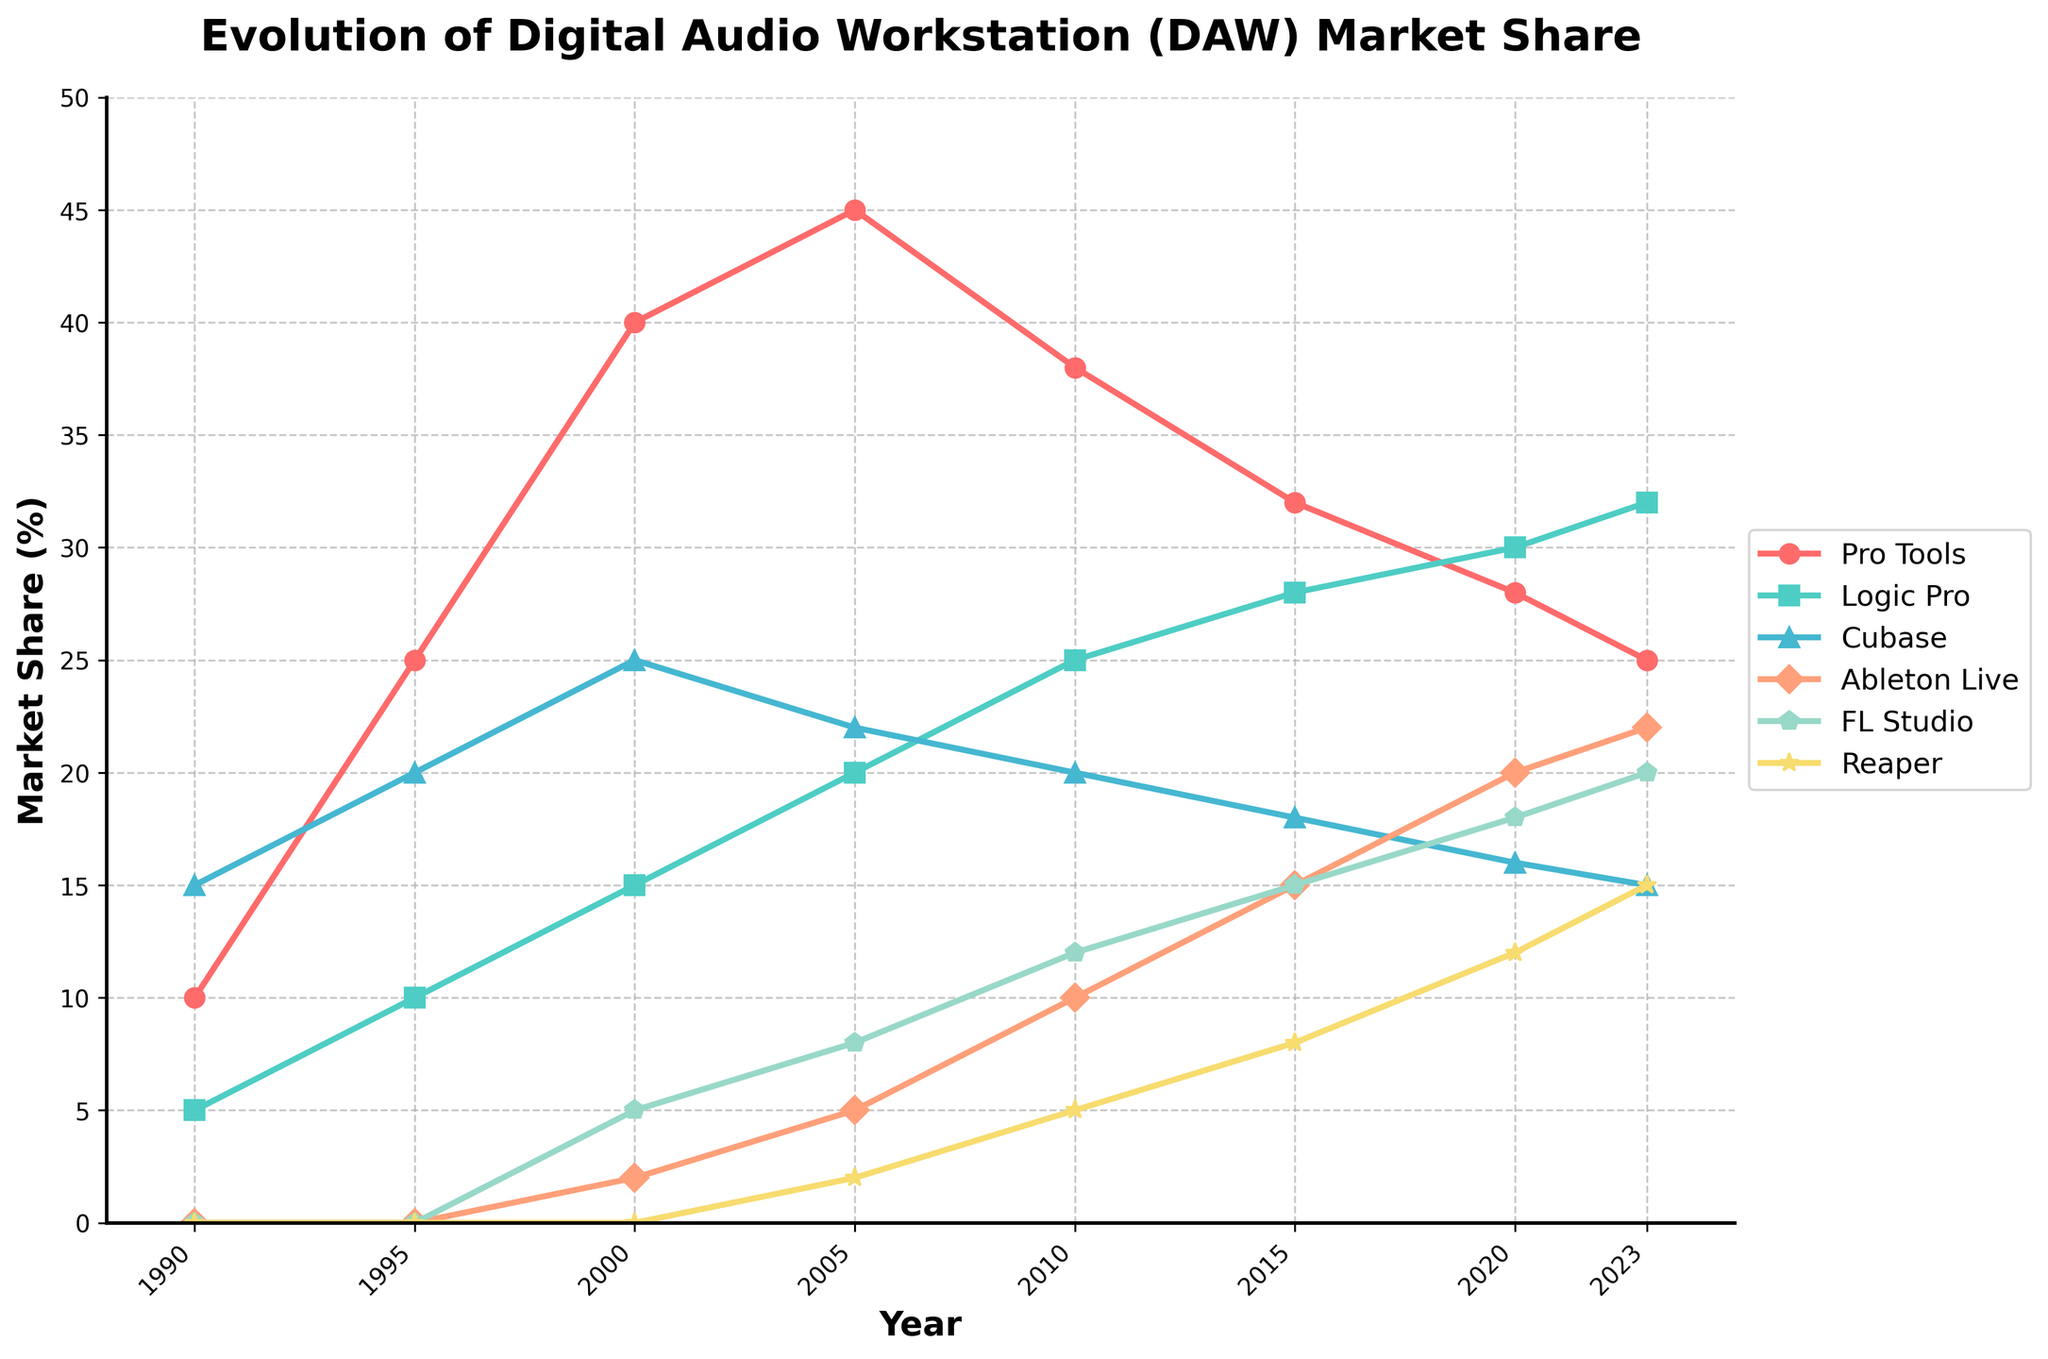What was the market share of Pro Tools and Logic Pro in 1995 combined? To find the combined market share of Pro Tools and Logic Pro in 1995, locate the data points for both in the year 1995. Pro Tools had a 25% market share and Logic Pro had 10%. Adding these together gives 25 + 10 = 35.
Answer: 35 Which DAW had the highest market share in the year 2000? Look at the data points for each DAW in the year 2000. Pro Tools had 40%, Logic Pro had 15%, Cubase had 25%, Ableton Live had 2%, FL Studio had 5%, and Reaper had 0%. Pro Tools had the highest market share with 40%.
Answer: Pro Tools Between which two consecutive years did Ableton Live see the largest increase in market share? To find the period when Ableton Live saw the largest increase, calculate the year-on-year differences: 2000-2005: 5-2=3, 2005-2010: 10-5=5, 2010-2015: 15-10=5, 2015-2020: 20-15=5, 2020-2023: 22-20=2. The largest increase was between 2005 to 2010, 2010 to 2015, and 2015 to 2020.
Answer: 2005 to 2010, 2010 to 2015, 2015 to 2020 How has the market share of FL Studio changed from 2005 to 2023? Identify FL Studio's market share at 2005 (8%) and 2023 (20%). The change in market share is 20 - 8 = 12, showing an increase of 12 percentage points.
Answer: Increased by 12 Which DAW had the smallest market share in 2015? Check the market share data for 2015: Pro Tools 32%, Logic Pro 28%, Cubase 18%, Ableton Live 15%, FL Studio 15%, Reaper 8%. Reaper had the smallest market share at 8%.
Answer: Reaper In which year did Reaper reach a double-digit market share for the first time? Review Reaper's market share across the years: 1990 (0%), 1995 (0%), 2000 (0%), 2005 (2%), 2010 (5%), 2015 (8%), 2020 (12%), 2023 (15%). The first double-digit market share was in 2020 with 12%.
Answer: 2020 Did Logic Pro ever surpass Pro Tools in market share? If so, when was the first time? Compare the market shares of Logic Pro and Pro Tools across all years. Logic Pro exceeds Pro Tools for the first time in 2020: Logic Pro (30%) vs. Pro Tools (28%).
Answer: 2020 